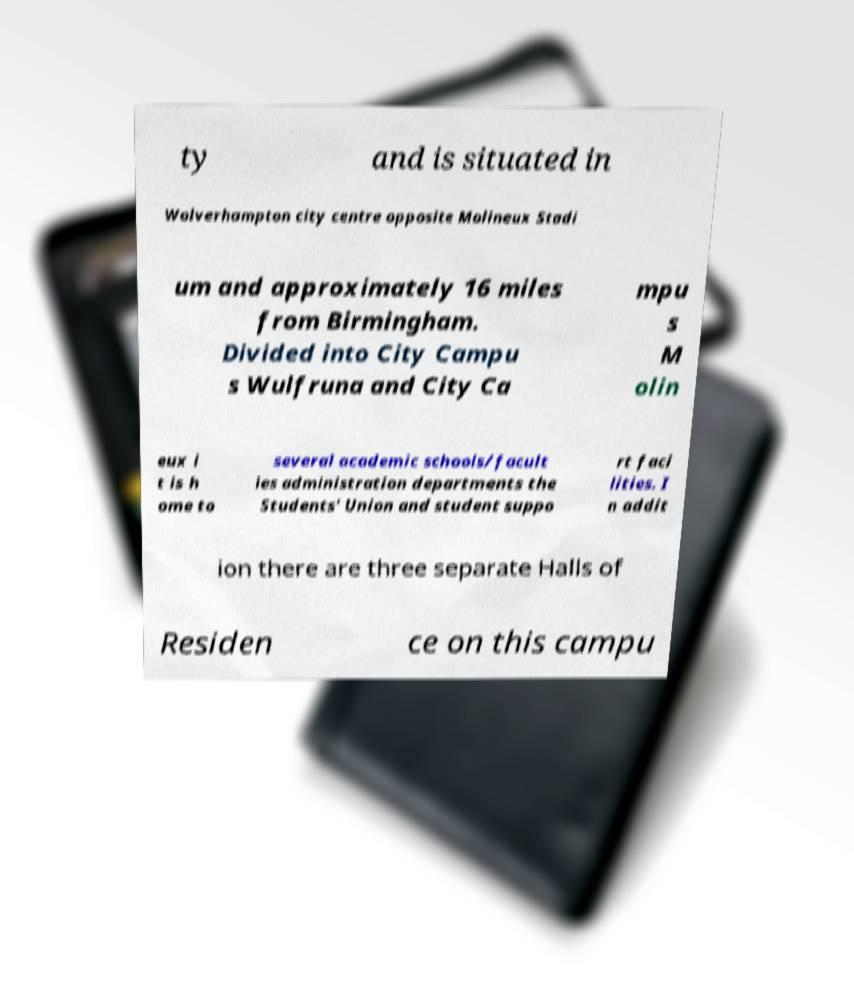Can you read and provide the text displayed in the image?This photo seems to have some interesting text. Can you extract and type it out for me? ty and is situated in Wolverhampton city centre opposite Molineux Stadi um and approximately 16 miles from Birmingham. Divided into City Campu s Wulfruna and City Ca mpu s M olin eux i t is h ome to several academic schools/facult ies administration departments the Students' Union and student suppo rt faci lities. I n addit ion there are three separate Halls of Residen ce on this campu 